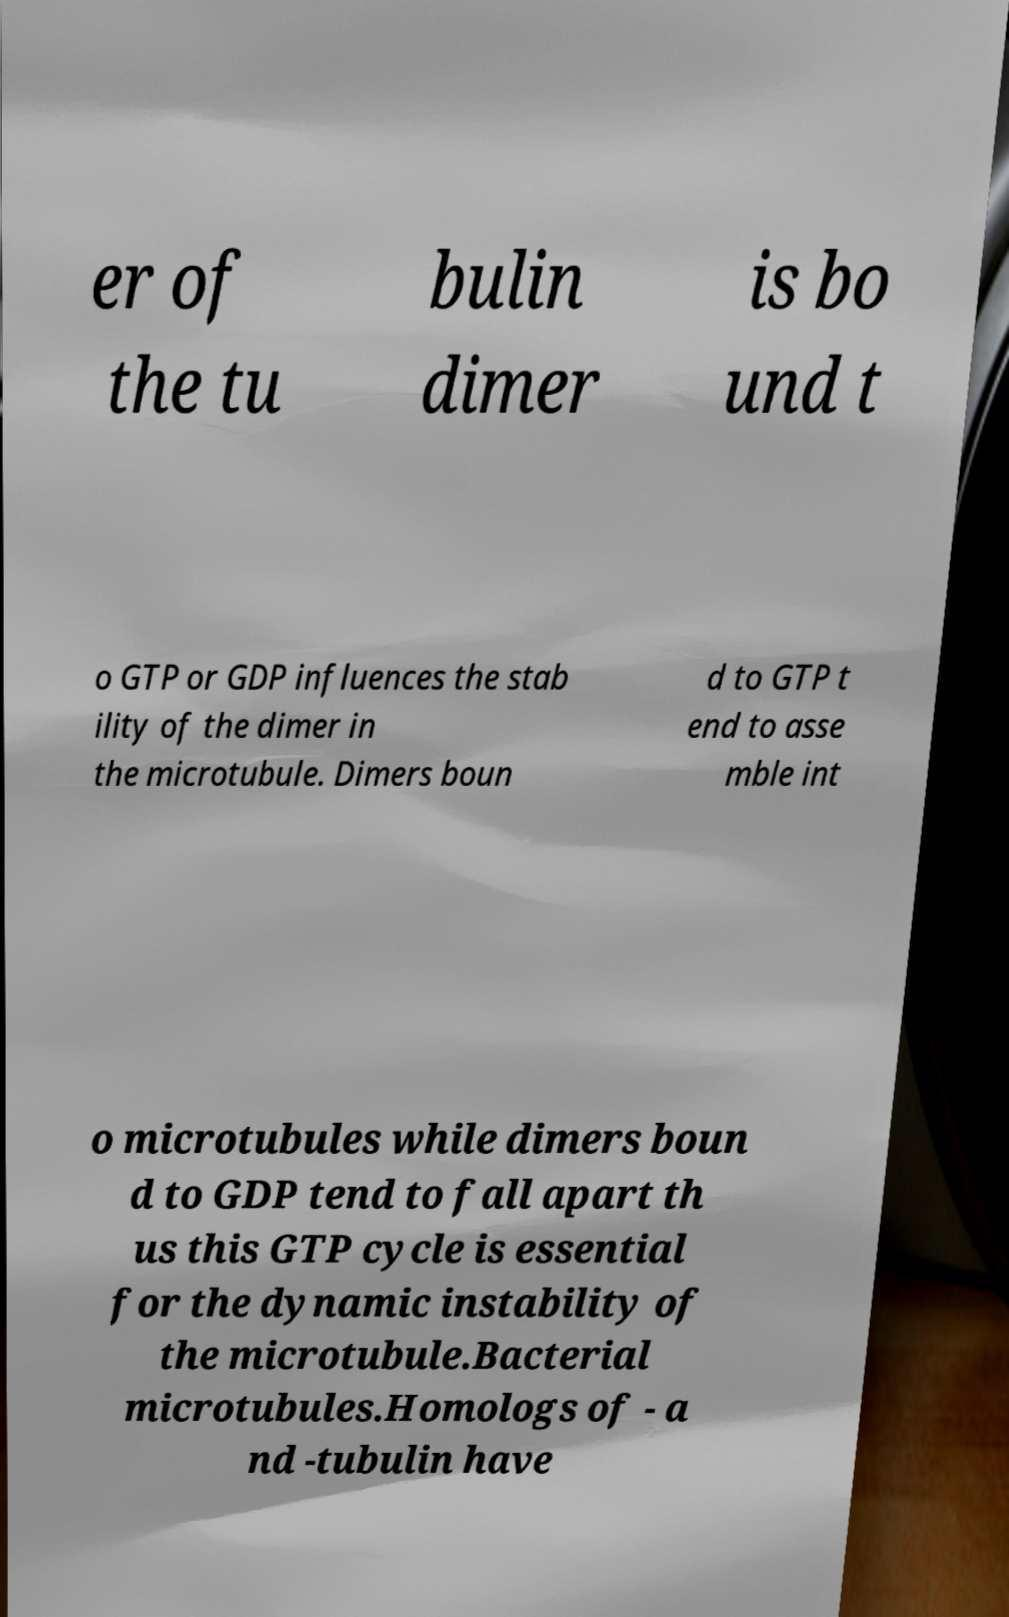What messages or text are displayed in this image? I need them in a readable, typed format. er of the tu bulin dimer is bo und t o GTP or GDP influences the stab ility of the dimer in the microtubule. Dimers boun d to GTP t end to asse mble int o microtubules while dimers boun d to GDP tend to fall apart th us this GTP cycle is essential for the dynamic instability of the microtubule.Bacterial microtubules.Homologs of - a nd -tubulin have 